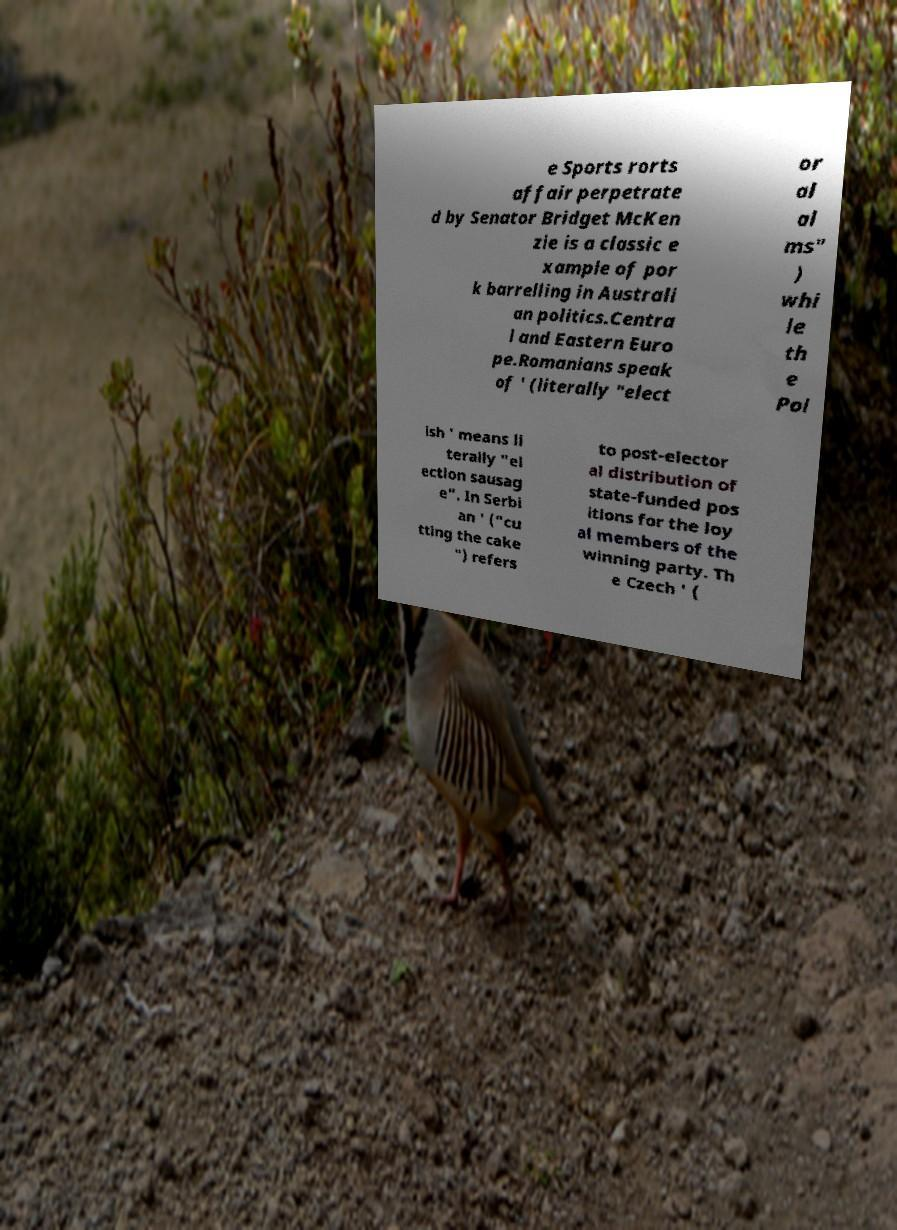Can you accurately transcribe the text from the provided image for me? e Sports rorts affair perpetrate d by Senator Bridget McKen zie is a classic e xample of por k barrelling in Australi an politics.Centra l and Eastern Euro pe.Romanians speak of ' (literally "elect or al al ms" ) whi le th e Pol ish ' means li terally "el ection sausag e". In Serbi an ' ("cu tting the cake ") refers to post-elector al distribution of state-funded pos itions for the loy al members of the winning party. Th e Czech ' ( 